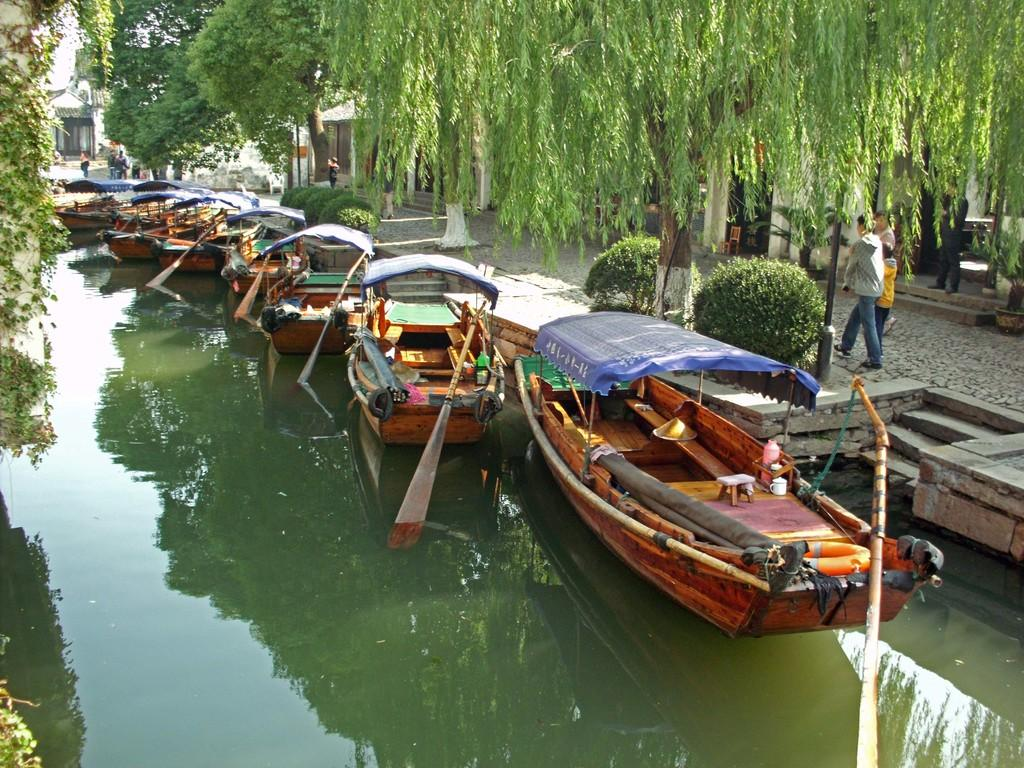What is the main element in the image? There is water in the image. What is on the water? There are boats on the water. What can be seen in the background of the image? There are trees, persons, and buildings in the background of the image. What type of guitar is being played by the person in the image? There is no guitar present in the image. What flavor of jam is being served on the boats in the image? There is no jam present in the image; it features water, boats, and background elements. 